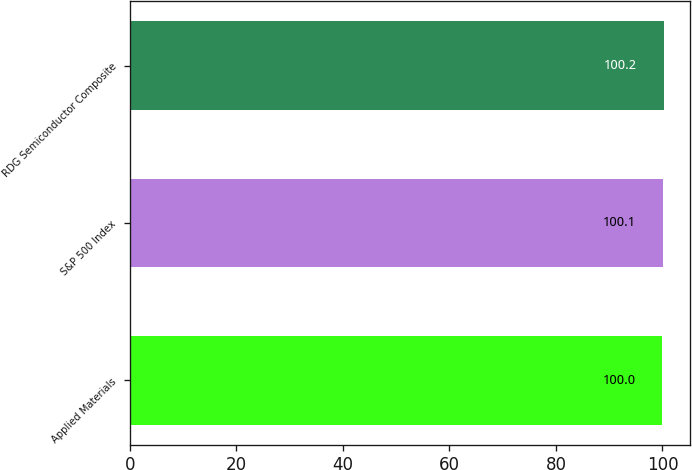Convert chart. <chart><loc_0><loc_0><loc_500><loc_500><bar_chart><fcel>Applied Materials<fcel>S&P 500 Index<fcel>RDG Semiconductor Composite<nl><fcel>100<fcel>100.1<fcel>100.2<nl></chart> 